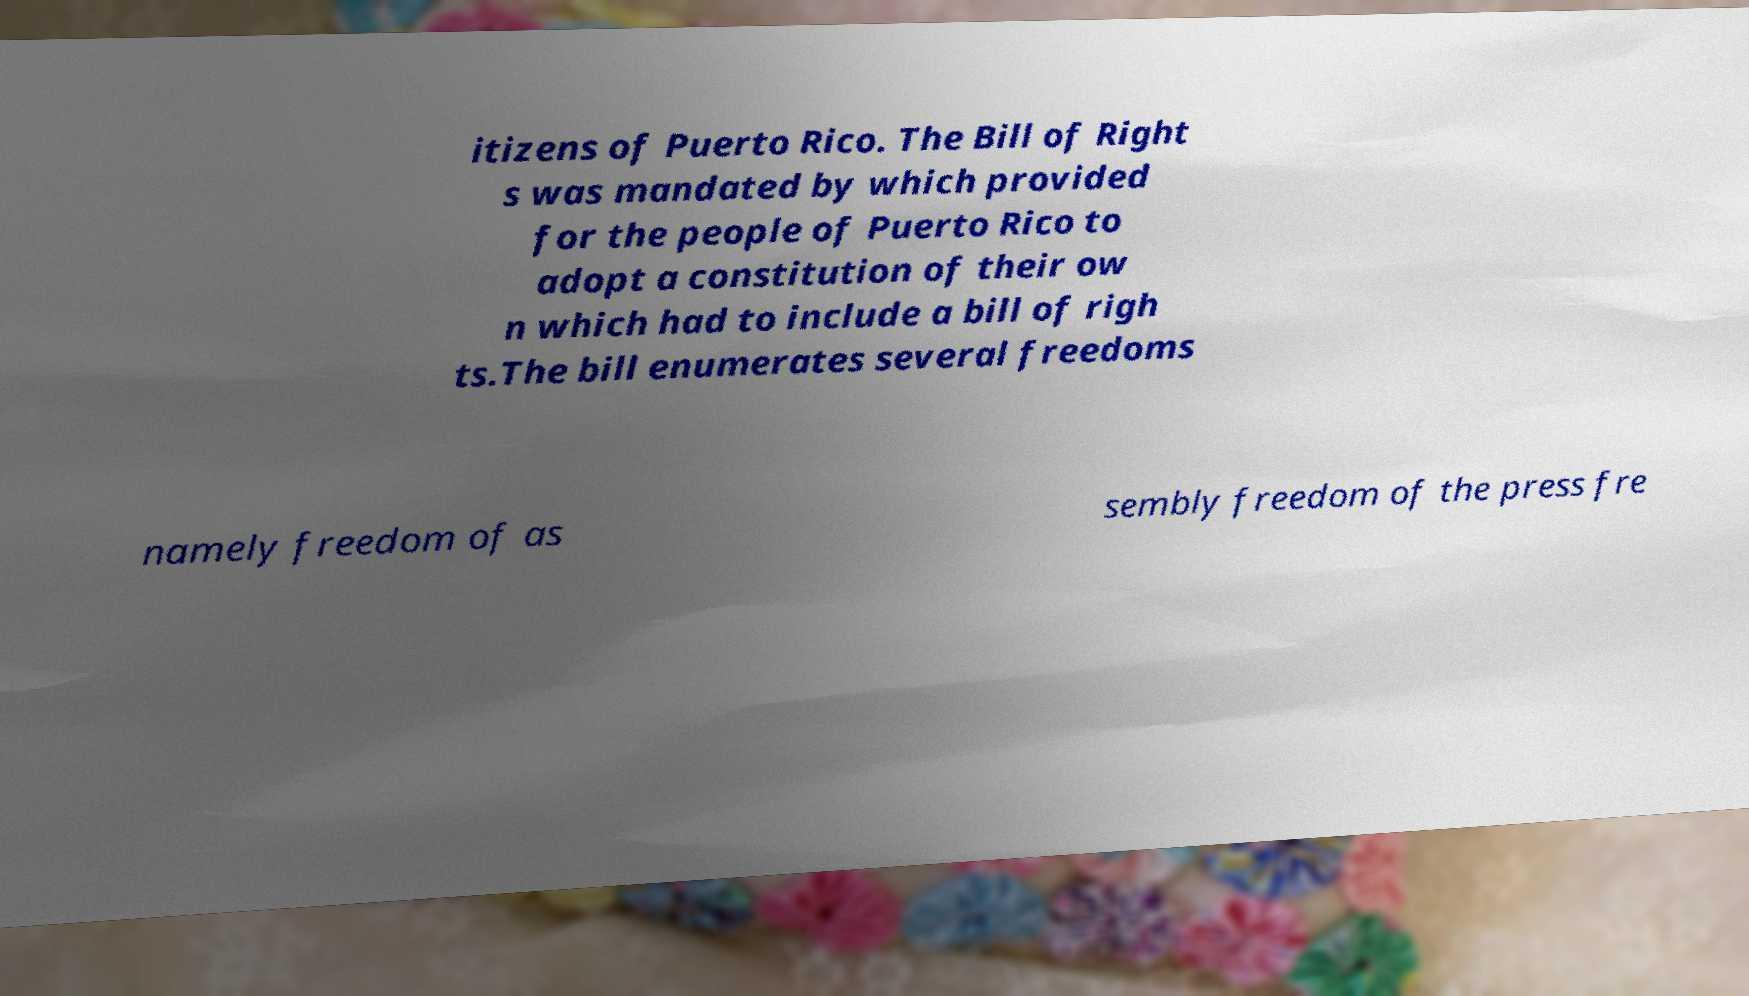Could you assist in decoding the text presented in this image and type it out clearly? itizens of Puerto Rico. The Bill of Right s was mandated by which provided for the people of Puerto Rico to adopt a constitution of their ow n which had to include a bill of righ ts.The bill enumerates several freedoms namely freedom of as sembly freedom of the press fre 